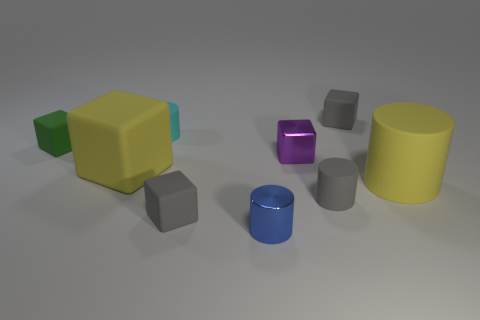Subtract all tiny cyan cylinders. How many cylinders are left? 3 Subtract all blue cylinders. How many cylinders are left? 3 Subtract all blue cylinders. How many green cubes are left? 1 Subtract all gray rubber objects. Subtract all big rubber things. How many objects are left? 4 Add 9 large yellow matte cubes. How many large yellow matte cubes are left? 10 Add 1 metal cylinders. How many metal cylinders exist? 2 Subtract 1 yellow blocks. How many objects are left? 8 Subtract all cylinders. How many objects are left? 5 Subtract 1 blocks. How many blocks are left? 4 Subtract all green blocks. Subtract all green cylinders. How many blocks are left? 4 